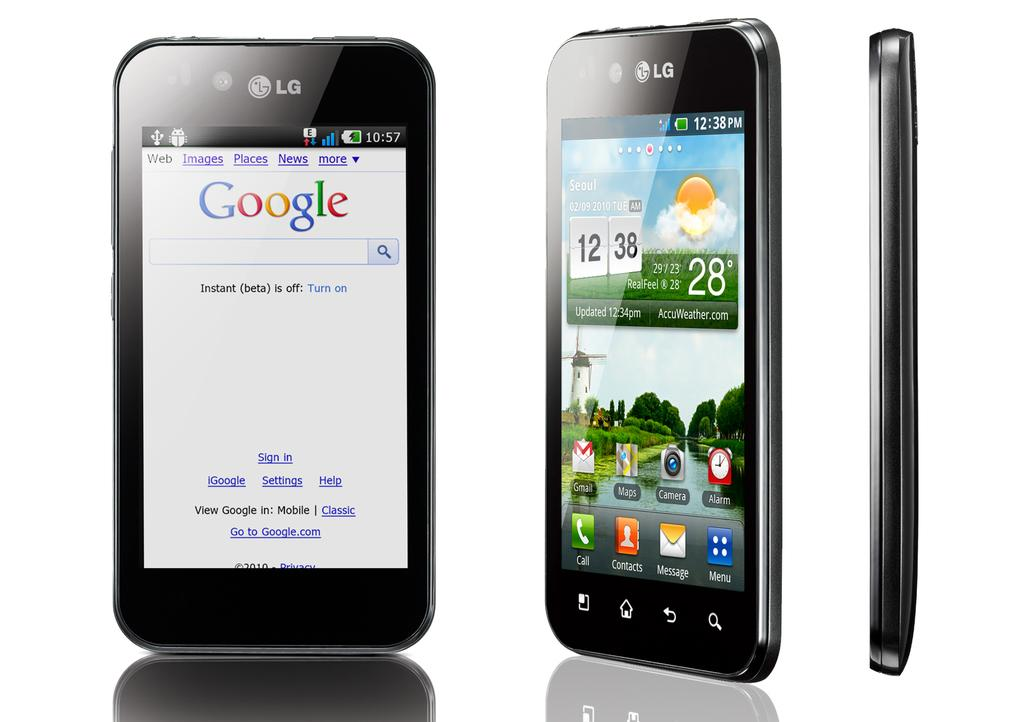<image>
Provide a brief description of the given image. An image of a phone taken at 12:38 on a 28° day. 